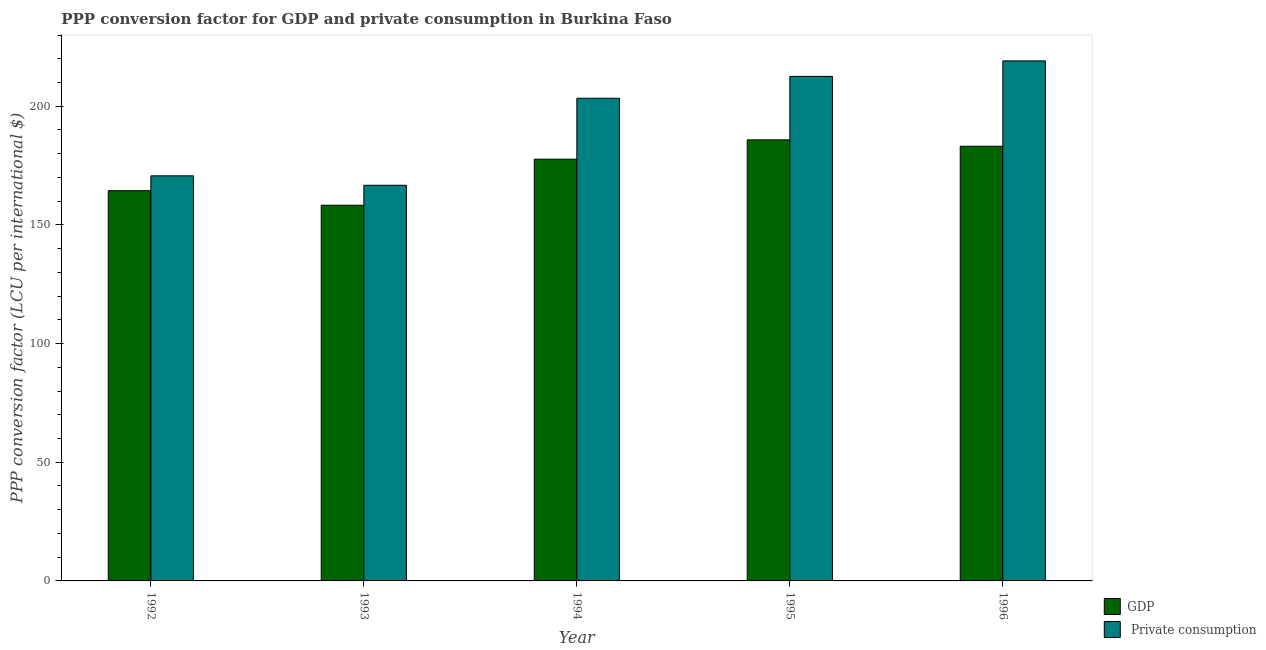How many different coloured bars are there?
Your answer should be compact. 2. How many groups of bars are there?
Offer a very short reply. 5. Are the number of bars per tick equal to the number of legend labels?
Keep it short and to the point. Yes. How many bars are there on the 2nd tick from the left?
Offer a very short reply. 2. What is the label of the 1st group of bars from the left?
Your answer should be very brief. 1992. In how many cases, is the number of bars for a given year not equal to the number of legend labels?
Provide a short and direct response. 0. What is the ppp conversion factor for gdp in 1993?
Offer a terse response. 158.29. Across all years, what is the maximum ppp conversion factor for private consumption?
Give a very brief answer. 219.11. Across all years, what is the minimum ppp conversion factor for private consumption?
Offer a very short reply. 166.7. In which year was the ppp conversion factor for gdp maximum?
Your answer should be compact. 1995. What is the total ppp conversion factor for private consumption in the graph?
Make the answer very short. 972.43. What is the difference between the ppp conversion factor for private consumption in 1992 and that in 1996?
Provide a short and direct response. -48.44. What is the difference between the ppp conversion factor for gdp in 1994 and the ppp conversion factor for private consumption in 1995?
Your answer should be compact. -8.15. What is the average ppp conversion factor for gdp per year?
Offer a very short reply. 173.88. In the year 1992, what is the difference between the ppp conversion factor for gdp and ppp conversion factor for private consumption?
Provide a short and direct response. 0. What is the ratio of the ppp conversion factor for gdp in 1992 to that in 1994?
Provide a succinct answer. 0.93. Is the ppp conversion factor for gdp in 1992 less than that in 1994?
Your answer should be compact. Yes. What is the difference between the highest and the second highest ppp conversion factor for private consumption?
Offer a terse response. 6.54. What is the difference between the highest and the lowest ppp conversion factor for private consumption?
Provide a short and direct response. 52.41. Is the sum of the ppp conversion factor for private consumption in 1992 and 1993 greater than the maximum ppp conversion factor for gdp across all years?
Keep it short and to the point. Yes. What does the 1st bar from the left in 1994 represents?
Provide a short and direct response. GDP. What does the 1st bar from the right in 1995 represents?
Offer a very short reply.  Private consumption. Are all the bars in the graph horizontal?
Your answer should be compact. No. Does the graph contain any zero values?
Provide a short and direct response. No. Where does the legend appear in the graph?
Your answer should be very brief. Bottom right. How many legend labels are there?
Provide a succinct answer. 2. What is the title of the graph?
Provide a short and direct response. PPP conversion factor for GDP and private consumption in Burkina Faso. What is the label or title of the X-axis?
Provide a succinct answer. Year. What is the label or title of the Y-axis?
Give a very brief answer. PPP conversion factor (LCU per international $). What is the PPP conversion factor (LCU per international $) of GDP in 1992?
Your answer should be compact. 164.43. What is the PPP conversion factor (LCU per international $) of  Private consumption in 1992?
Provide a succinct answer. 170.67. What is the PPP conversion factor (LCU per international $) in GDP in 1993?
Your answer should be compact. 158.29. What is the PPP conversion factor (LCU per international $) of  Private consumption in 1993?
Offer a terse response. 166.7. What is the PPP conversion factor (LCU per international $) in GDP in 1994?
Give a very brief answer. 177.68. What is the PPP conversion factor (LCU per international $) in  Private consumption in 1994?
Your answer should be very brief. 203.37. What is the PPP conversion factor (LCU per international $) in GDP in 1995?
Ensure brevity in your answer.  185.84. What is the PPP conversion factor (LCU per international $) of  Private consumption in 1995?
Your answer should be very brief. 212.57. What is the PPP conversion factor (LCU per international $) of GDP in 1996?
Ensure brevity in your answer.  183.14. What is the PPP conversion factor (LCU per international $) in  Private consumption in 1996?
Make the answer very short. 219.11. Across all years, what is the maximum PPP conversion factor (LCU per international $) of GDP?
Your answer should be compact. 185.84. Across all years, what is the maximum PPP conversion factor (LCU per international $) in  Private consumption?
Your response must be concise. 219.11. Across all years, what is the minimum PPP conversion factor (LCU per international $) of GDP?
Provide a short and direct response. 158.29. Across all years, what is the minimum PPP conversion factor (LCU per international $) of  Private consumption?
Provide a succinct answer. 166.7. What is the total PPP conversion factor (LCU per international $) of GDP in the graph?
Offer a terse response. 869.39. What is the total PPP conversion factor (LCU per international $) of  Private consumption in the graph?
Provide a short and direct response. 972.43. What is the difference between the PPP conversion factor (LCU per international $) in GDP in 1992 and that in 1993?
Offer a very short reply. 6.14. What is the difference between the PPP conversion factor (LCU per international $) of  Private consumption in 1992 and that in 1993?
Make the answer very short. 3.98. What is the difference between the PPP conversion factor (LCU per international $) of GDP in 1992 and that in 1994?
Your answer should be very brief. -13.25. What is the difference between the PPP conversion factor (LCU per international $) of  Private consumption in 1992 and that in 1994?
Offer a terse response. -32.69. What is the difference between the PPP conversion factor (LCU per international $) in GDP in 1992 and that in 1995?
Provide a short and direct response. -21.41. What is the difference between the PPP conversion factor (LCU per international $) in  Private consumption in 1992 and that in 1995?
Make the answer very short. -41.9. What is the difference between the PPP conversion factor (LCU per international $) in GDP in 1992 and that in 1996?
Your answer should be very brief. -18.71. What is the difference between the PPP conversion factor (LCU per international $) in  Private consumption in 1992 and that in 1996?
Provide a short and direct response. -48.44. What is the difference between the PPP conversion factor (LCU per international $) of GDP in 1993 and that in 1994?
Make the answer very short. -19.39. What is the difference between the PPP conversion factor (LCU per international $) in  Private consumption in 1993 and that in 1994?
Your response must be concise. -36.67. What is the difference between the PPP conversion factor (LCU per international $) in GDP in 1993 and that in 1995?
Make the answer very short. -27.54. What is the difference between the PPP conversion factor (LCU per international $) of  Private consumption in 1993 and that in 1995?
Offer a very short reply. -45.87. What is the difference between the PPP conversion factor (LCU per international $) in GDP in 1993 and that in 1996?
Keep it short and to the point. -24.85. What is the difference between the PPP conversion factor (LCU per international $) in  Private consumption in 1993 and that in 1996?
Offer a very short reply. -52.41. What is the difference between the PPP conversion factor (LCU per international $) in GDP in 1994 and that in 1995?
Make the answer very short. -8.15. What is the difference between the PPP conversion factor (LCU per international $) of  Private consumption in 1994 and that in 1995?
Provide a short and direct response. -9.21. What is the difference between the PPP conversion factor (LCU per international $) of GDP in 1994 and that in 1996?
Provide a succinct answer. -5.46. What is the difference between the PPP conversion factor (LCU per international $) in  Private consumption in 1994 and that in 1996?
Ensure brevity in your answer.  -15.74. What is the difference between the PPP conversion factor (LCU per international $) of GDP in 1995 and that in 1996?
Your answer should be compact. 2.7. What is the difference between the PPP conversion factor (LCU per international $) of  Private consumption in 1995 and that in 1996?
Offer a terse response. -6.54. What is the difference between the PPP conversion factor (LCU per international $) of GDP in 1992 and the PPP conversion factor (LCU per international $) of  Private consumption in 1993?
Offer a very short reply. -2.27. What is the difference between the PPP conversion factor (LCU per international $) in GDP in 1992 and the PPP conversion factor (LCU per international $) in  Private consumption in 1994?
Your response must be concise. -38.94. What is the difference between the PPP conversion factor (LCU per international $) of GDP in 1992 and the PPP conversion factor (LCU per international $) of  Private consumption in 1995?
Give a very brief answer. -48.14. What is the difference between the PPP conversion factor (LCU per international $) of GDP in 1992 and the PPP conversion factor (LCU per international $) of  Private consumption in 1996?
Ensure brevity in your answer.  -54.68. What is the difference between the PPP conversion factor (LCU per international $) in GDP in 1993 and the PPP conversion factor (LCU per international $) in  Private consumption in 1994?
Your answer should be compact. -45.07. What is the difference between the PPP conversion factor (LCU per international $) of GDP in 1993 and the PPP conversion factor (LCU per international $) of  Private consumption in 1995?
Provide a short and direct response. -54.28. What is the difference between the PPP conversion factor (LCU per international $) of GDP in 1993 and the PPP conversion factor (LCU per international $) of  Private consumption in 1996?
Offer a very short reply. -60.82. What is the difference between the PPP conversion factor (LCU per international $) in GDP in 1994 and the PPP conversion factor (LCU per international $) in  Private consumption in 1995?
Provide a succinct answer. -34.89. What is the difference between the PPP conversion factor (LCU per international $) in GDP in 1994 and the PPP conversion factor (LCU per international $) in  Private consumption in 1996?
Provide a succinct answer. -41.43. What is the difference between the PPP conversion factor (LCU per international $) of GDP in 1995 and the PPP conversion factor (LCU per international $) of  Private consumption in 1996?
Keep it short and to the point. -33.28. What is the average PPP conversion factor (LCU per international $) in GDP per year?
Your response must be concise. 173.88. What is the average PPP conversion factor (LCU per international $) in  Private consumption per year?
Your answer should be very brief. 194.49. In the year 1992, what is the difference between the PPP conversion factor (LCU per international $) in GDP and PPP conversion factor (LCU per international $) in  Private consumption?
Make the answer very short. -6.24. In the year 1993, what is the difference between the PPP conversion factor (LCU per international $) of GDP and PPP conversion factor (LCU per international $) of  Private consumption?
Offer a very short reply. -8.41. In the year 1994, what is the difference between the PPP conversion factor (LCU per international $) in GDP and PPP conversion factor (LCU per international $) in  Private consumption?
Provide a succinct answer. -25.68. In the year 1995, what is the difference between the PPP conversion factor (LCU per international $) in GDP and PPP conversion factor (LCU per international $) in  Private consumption?
Keep it short and to the point. -26.74. In the year 1996, what is the difference between the PPP conversion factor (LCU per international $) of GDP and PPP conversion factor (LCU per international $) of  Private consumption?
Make the answer very short. -35.97. What is the ratio of the PPP conversion factor (LCU per international $) of GDP in 1992 to that in 1993?
Ensure brevity in your answer.  1.04. What is the ratio of the PPP conversion factor (LCU per international $) in  Private consumption in 1992 to that in 1993?
Provide a succinct answer. 1.02. What is the ratio of the PPP conversion factor (LCU per international $) of GDP in 1992 to that in 1994?
Offer a very short reply. 0.93. What is the ratio of the PPP conversion factor (LCU per international $) of  Private consumption in 1992 to that in 1994?
Your answer should be compact. 0.84. What is the ratio of the PPP conversion factor (LCU per international $) of GDP in 1992 to that in 1995?
Offer a terse response. 0.88. What is the ratio of the PPP conversion factor (LCU per international $) in  Private consumption in 1992 to that in 1995?
Your answer should be compact. 0.8. What is the ratio of the PPP conversion factor (LCU per international $) in GDP in 1992 to that in 1996?
Give a very brief answer. 0.9. What is the ratio of the PPP conversion factor (LCU per international $) of  Private consumption in 1992 to that in 1996?
Your response must be concise. 0.78. What is the ratio of the PPP conversion factor (LCU per international $) of GDP in 1993 to that in 1994?
Give a very brief answer. 0.89. What is the ratio of the PPP conversion factor (LCU per international $) of  Private consumption in 1993 to that in 1994?
Offer a very short reply. 0.82. What is the ratio of the PPP conversion factor (LCU per international $) in GDP in 1993 to that in 1995?
Keep it short and to the point. 0.85. What is the ratio of the PPP conversion factor (LCU per international $) in  Private consumption in 1993 to that in 1995?
Your answer should be very brief. 0.78. What is the ratio of the PPP conversion factor (LCU per international $) of GDP in 1993 to that in 1996?
Your response must be concise. 0.86. What is the ratio of the PPP conversion factor (LCU per international $) of  Private consumption in 1993 to that in 1996?
Keep it short and to the point. 0.76. What is the ratio of the PPP conversion factor (LCU per international $) of GDP in 1994 to that in 1995?
Make the answer very short. 0.96. What is the ratio of the PPP conversion factor (LCU per international $) in  Private consumption in 1994 to that in 1995?
Provide a succinct answer. 0.96. What is the ratio of the PPP conversion factor (LCU per international $) of GDP in 1994 to that in 1996?
Provide a short and direct response. 0.97. What is the ratio of the PPP conversion factor (LCU per international $) of  Private consumption in 1994 to that in 1996?
Your answer should be compact. 0.93. What is the ratio of the PPP conversion factor (LCU per international $) of GDP in 1995 to that in 1996?
Offer a terse response. 1.01. What is the ratio of the PPP conversion factor (LCU per international $) of  Private consumption in 1995 to that in 1996?
Provide a short and direct response. 0.97. What is the difference between the highest and the second highest PPP conversion factor (LCU per international $) of GDP?
Ensure brevity in your answer.  2.7. What is the difference between the highest and the second highest PPP conversion factor (LCU per international $) of  Private consumption?
Your answer should be compact. 6.54. What is the difference between the highest and the lowest PPP conversion factor (LCU per international $) in GDP?
Keep it short and to the point. 27.54. What is the difference between the highest and the lowest PPP conversion factor (LCU per international $) of  Private consumption?
Make the answer very short. 52.41. 